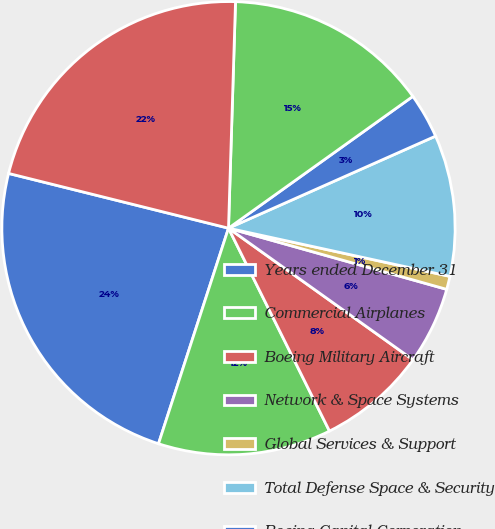Convert chart. <chart><loc_0><loc_0><loc_500><loc_500><pie_chart><fcel>Years ended December 31<fcel>Commercial Airplanes<fcel>Boeing Military Aircraft<fcel>Network & Space Systems<fcel>Global Services & Support<fcel>Total Defense Space & Security<fcel>Boeing Capital Corporation<fcel>Unallocated items eliminations<fcel>Total<nl><fcel>23.89%<fcel>12.35%<fcel>7.79%<fcel>5.51%<fcel>0.94%<fcel>10.07%<fcel>3.22%<fcel>14.63%<fcel>21.61%<nl></chart> 